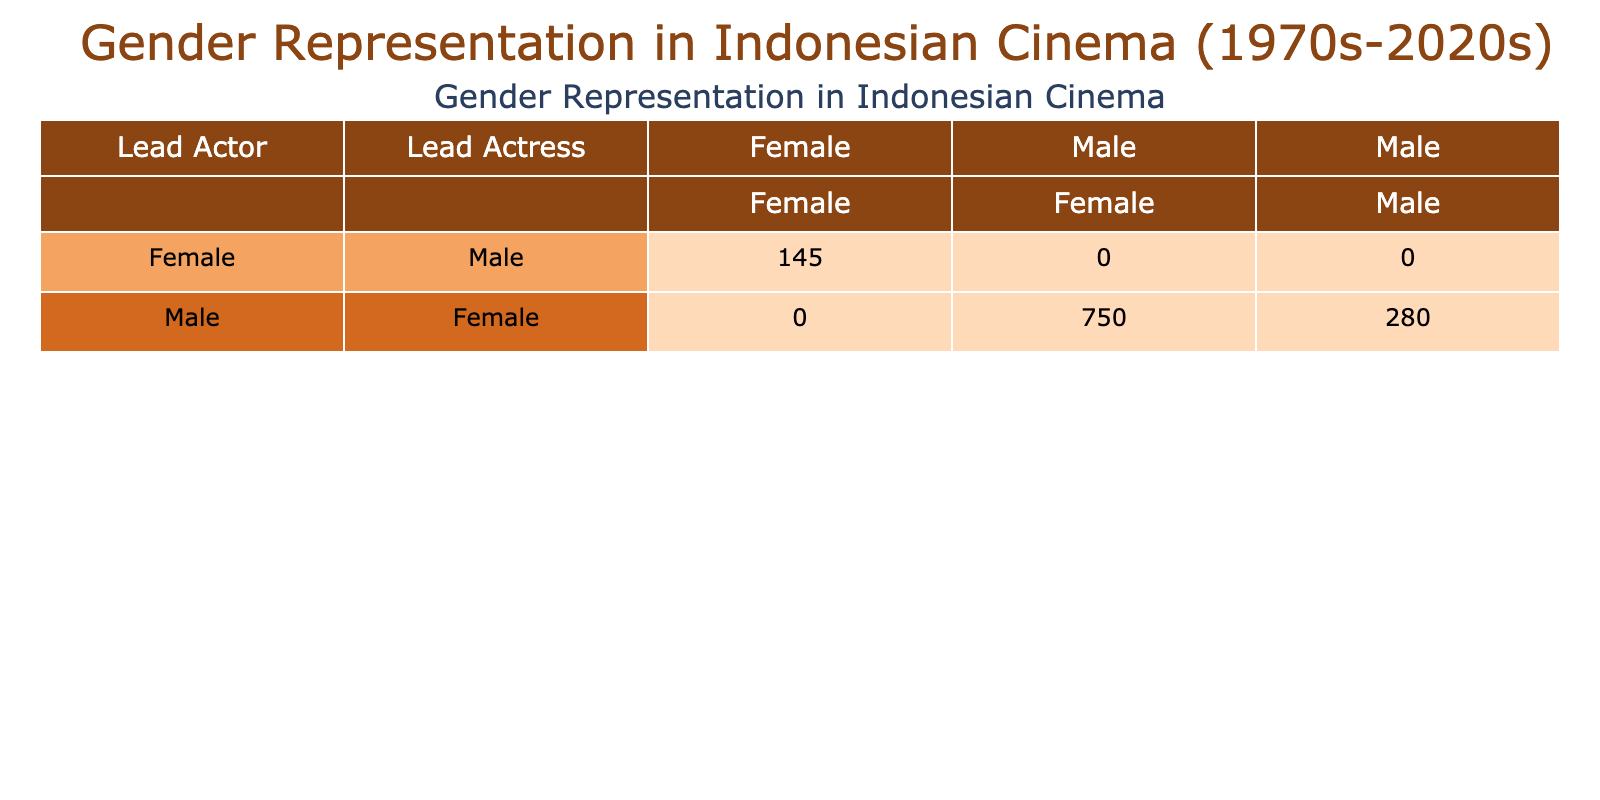What is the total number of films with a male lead actor and a female lead actress in the 1980s? From the table, we find the row for the 1980s with a male lead actor and a female lead actress. The total films for that row is 120.
Answer: 120 How many films feature a female lead actress and a male supporting actor in the 2010s? Referring to the 2010s row for the female lead actress with a male supporting actor, we see the total films listed is 35.
Answer: 35 Is there any decade where the number of films with a female lead actress and male supporting actor is more than 30? Checking the table entries for the female lead actress and male supporting actor, the 2000s (30) and 2010s (35) have values greater than 30. Thus, the statement is true.
Answer: Yes What was the increment of films starring male lead actors and male supporting actors from the 1970s to the 2000s? For male lead actors and male supporting actors, we note the total films in 1970s is 30 and in 2000s it is 60. The increment is 60 - 30 = 30.
Answer: 30 Which decade has the lowest number of films with a female lead actress and female supporting actress? By quickly scanning the table, the 2020s has the lowest number with 15 films in the specified category.
Answer: 2020s What is the total number of films featuring lead actress female and supporting actress female in the 1990s? Looking at the row for the 1990s, the total films for the female lead actress and female supporting actress category is 25.
Answer: 25 During the 70s and 80s, how many films had male lead actors and male supporting actors combined? Combining the totals from these decades: 30 (1970s) + 40 (1980s) = 70 films combined.
Answer: 70 In which decade did the number of films with female lead actresses and female supporting actors peak? Checking the totals in the table, the 2010s (35) reveal the peak for this category when compared to other decades.
Answer: 2010s How many total films feature lead actors regardless of gender across all decades? To find this, we need to add all films regardless of female or male. For male lead actor (100 + 120 + 140 + 150 + 160 + 80) = 850, female (20 + 20 + 25 + 30 + 35 + 15) = 135. So total is 850 + 135 = 985.
Answer: 985 